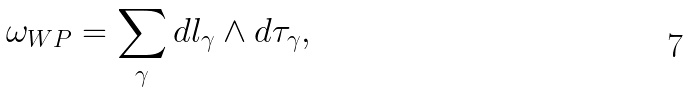<formula> <loc_0><loc_0><loc_500><loc_500>\omega _ { W P } = \sum _ { \gamma } d l _ { \gamma } \wedge d \tau _ { \gamma } ,</formula> 